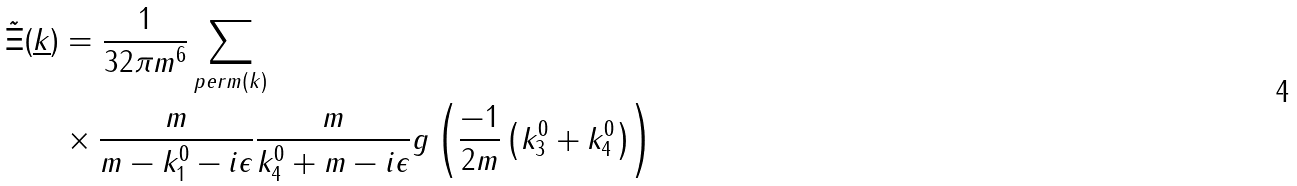Convert formula to latex. <formula><loc_0><loc_0><loc_500><loc_500>\tilde { \Xi } ( \underline { k } ) & = \frac { 1 } { 3 2 \pi m ^ { 6 } } \sum _ { p e r m ( k ) } \\ & \times \frac { m } { m - k _ { 1 } ^ { 0 } - i \epsilon } \frac { m } { k _ { 4 } ^ { 0 } + m - i \epsilon } g \left ( \frac { - 1 } { 2 m } \left ( k _ { 3 } ^ { 0 } + k _ { 4 } ^ { 0 } \right ) \right )</formula> 